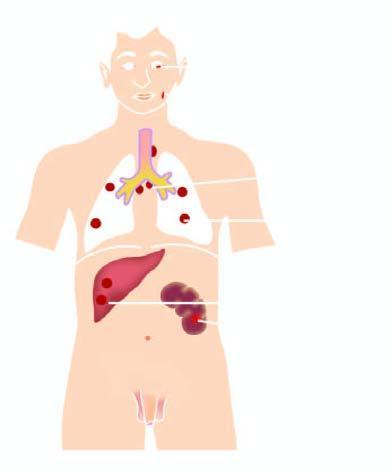re the lesions predominantly seen in lymph nodes and throughout lung parenchyma?
Answer the question using a single word or phrase. Yes 